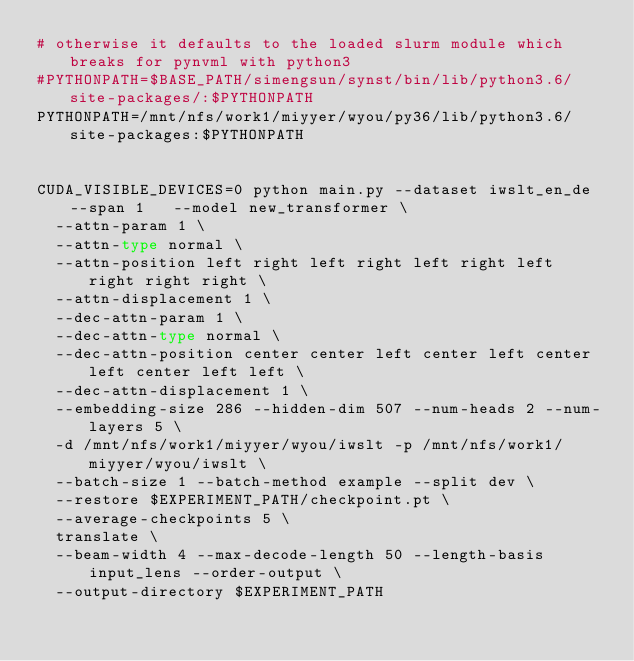Convert code to text. <code><loc_0><loc_0><loc_500><loc_500><_Bash_># otherwise it defaults to the loaded slurm module which breaks for pynvml with python3
#PYTHONPATH=$BASE_PATH/simengsun/synst/bin/lib/python3.6/site-packages/:$PYTHONPATH
PYTHONPATH=/mnt/nfs/work1/miyyer/wyou/py36/lib/python3.6/site-packages:$PYTHONPATH

	
CUDA_VISIBLE_DEVICES=0 python main.py --dataset iwslt_en_de --span 1   --model new_transformer \
  --attn-param 1 \
  --attn-type normal \
  --attn-position left right left right left right left right right right \
  --attn-displacement 1 \
  --dec-attn-param 1 \
  --dec-attn-type normal \
  --dec-attn-position center center left center left center left center left left \
  --dec-attn-displacement 1 \
  --embedding-size 286 --hidden-dim 507 --num-heads 2 --num-layers 5 \
  -d /mnt/nfs/work1/miyyer/wyou/iwslt -p /mnt/nfs/work1/miyyer/wyou/iwslt \
  --batch-size 1 --batch-method example --split dev \
  --restore $EXPERIMENT_PATH/checkpoint.pt \
  --average-checkpoints 5 \
  translate \
  --beam-width 4 --max-decode-length 50 --length-basis input_lens --order-output \
  --output-directory $EXPERIMENT_PATH
	</code> 